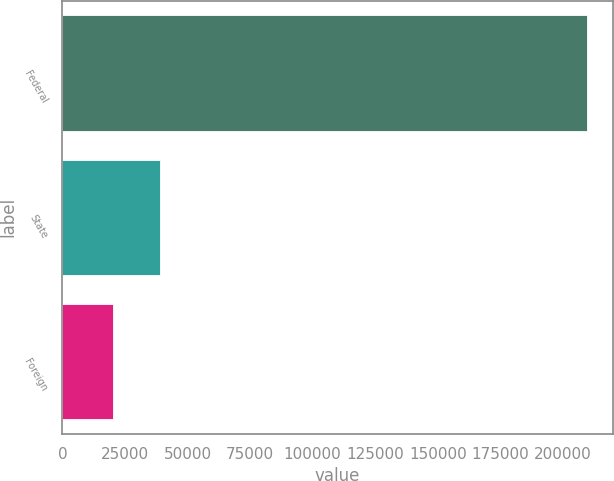Convert chart to OTSL. <chart><loc_0><loc_0><loc_500><loc_500><bar_chart><fcel>Federal<fcel>State<fcel>Foreign<nl><fcel>209499<fcel>39090.3<fcel>20156<nl></chart> 